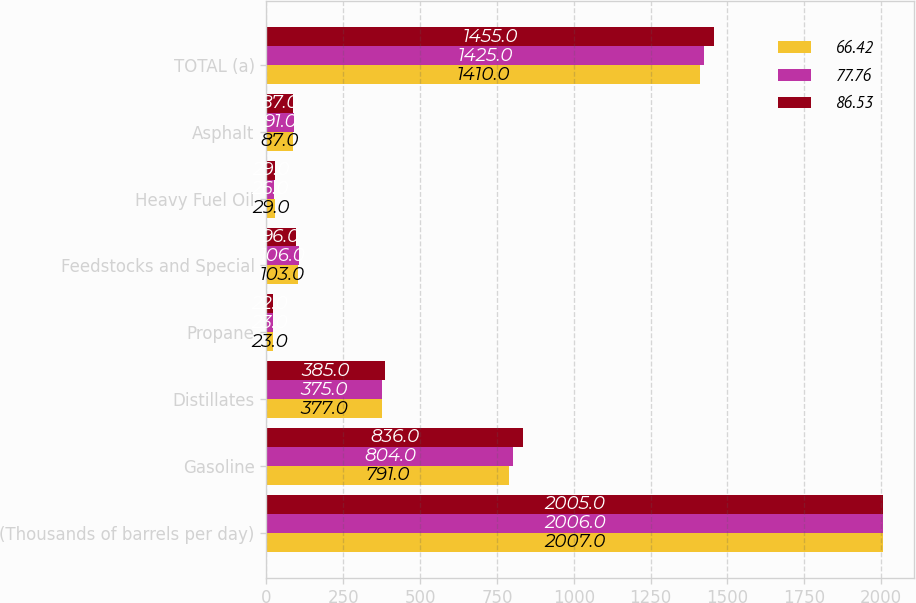Convert chart to OTSL. <chart><loc_0><loc_0><loc_500><loc_500><stacked_bar_chart><ecel><fcel>(Thousands of barrels per day)<fcel>Gasoline<fcel>Distillates<fcel>Propane<fcel>Feedstocks and Special<fcel>Heavy Fuel Oil<fcel>Asphalt<fcel>TOTAL (a)<nl><fcel>66.42<fcel>2007<fcel>791<fcel>377<fcel>23<fcel>103<fcel>29<fcel>87<fcel>1410<nl><fcel>77.76<fcel>2006<fcel>804<fcel>375<fcel>23<fcel>106<fcel>26<fcel>91<fcel>1425<nl><fcel>86.53<fcel>2005<fcel>836<fcel>385<fcel>22<fcel>96<fcel>29<fcel>87<fcel>1455<nl></chart> 